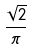Convert formula to latex. <formula><loc_0><loc_0><loc_500><loc_500>\frac { \sqrt { 2 } } { \pi }</formula> 